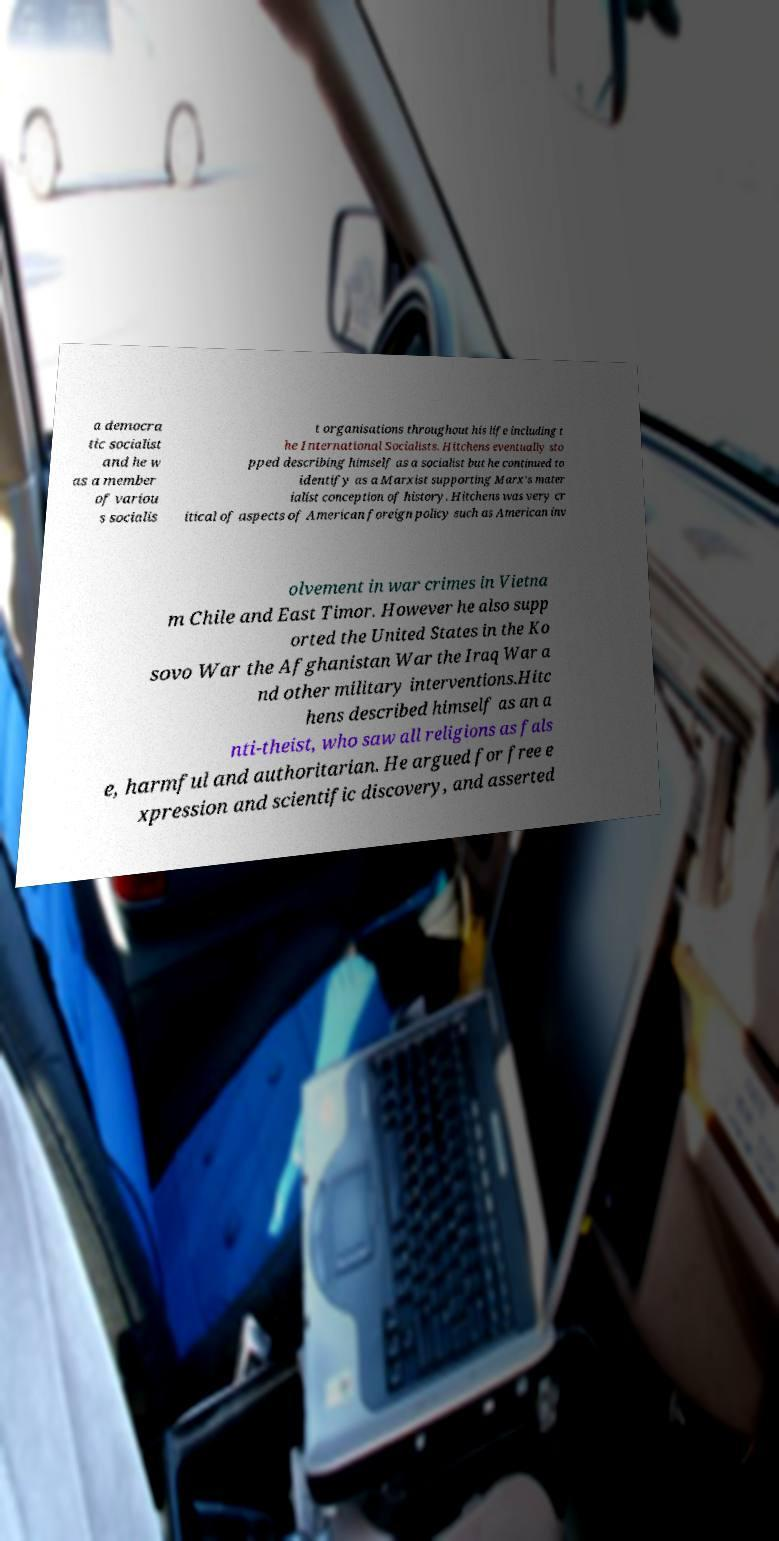Please read and relay the text visible in this image. What does it say? a democra tic socialist and he w as a member of variou s socialis t organisations throughout his life including t he International Socialists. Hitchens eventually sto pped describing himself as a socialist but he continued to identify as a Marxist supporting Marx's mater ialist conception of history. Hitchens was very cr itical of aspects of American foreign policy such as American inv olvement in war crimes in Vietna m Chile and East Timor. However he also supp orted the United States in the Ko sovo War the Afghanistan War the Iraq War a nd other military interventions.Hitc hens described himself as an a nti-theist, who saw all religions as fals e, harmful and authoritarian. He argued for free e xpression and scientific discovery, and asserted 